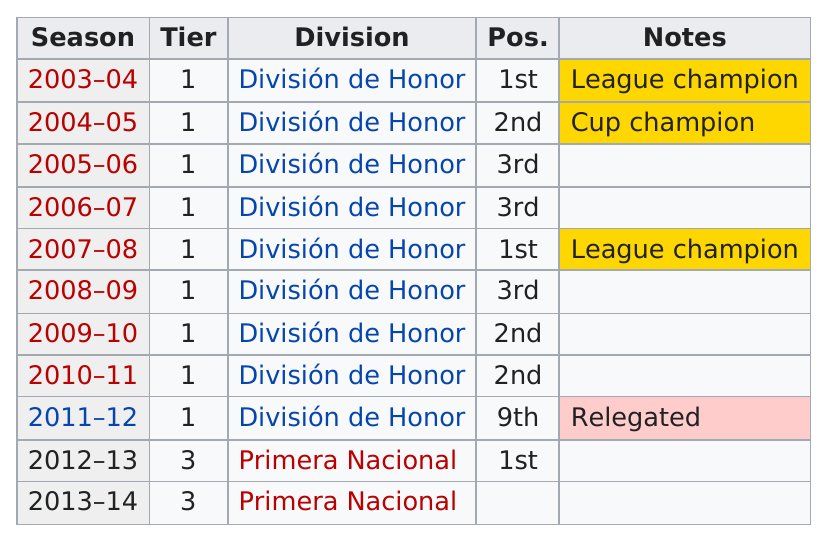Indicate a few pertinent items in this graphic. The last season that they finished in first place was the 2012-2013 season. Division de Honor has played more times than Primera Nacional. This team has placed second for a total of three years. Someone received third place in three seasons. Out of the tiers presented, which tier appears the most? 